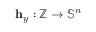<formula> <loc_0><loc_0><loc_500><loc_500>h _ { y } \colon \mathbb { Z } \rightarrow \mathbb { S } ^ { n }</formula> 